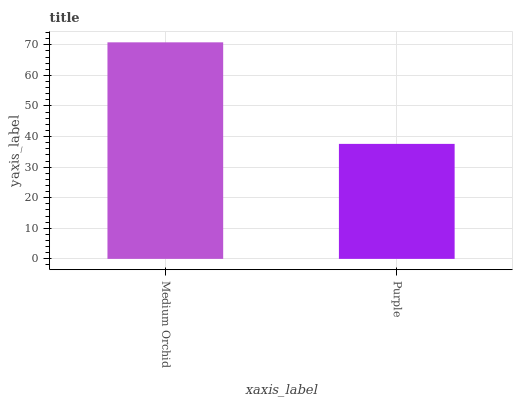Is Purple the minimum?
Answer yes or no. Yes. Is Medium Orchid the maximum?
Answer yes or no. Yes. Is Purple the maximum?
Answer yes or no. No. Is Medium Orchid greater than Purple?
Answer yes or no. Yes. Is Purple less than Medium Orchid?
Answer yes or no. Yes. Is Purple greater than Medium Orchid?
Answer yes or no. No. Is Medium Orchid less than Purple?
Answer yes or no. No. Is Medium Orchid the high median?
Answer yes or no. Yes. Is Purple the low median?
Answer yes or no. Yes. Is Purple the high median?
Answer yes or no. No. Is Medium Orchid the low median?
Answer yes or no. No. 